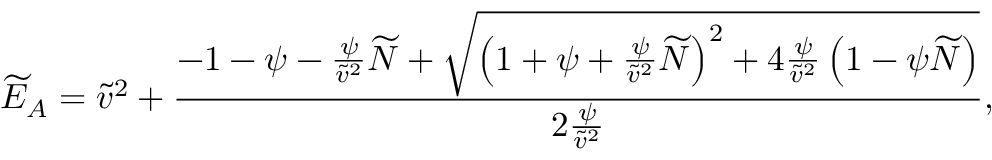<formula> <loc_0><loc_0><loc_500><loc_500>\widetilde { E } _ { A } = \widetilde { v } ^ { 2 } + \frac { - 1 - \psi - \frac { \psi } { \widetilde { v } ^ { 2 } } \widetilde { N } + \sqrt { \left ( 1 + \psi + \frac { \psi } { \widetilde { v } ^ { 2 } } \widetilde { N } \right ) ^ { 2 } + 4 \frac { \psi } { \widetilde { v } ^ { 2 } } \left ( 1 - \psi \widetilde { N } \right ) } } { 2 \frac { \psi } { \widetilde { v } ^ { 2 } } } ,</formula> 